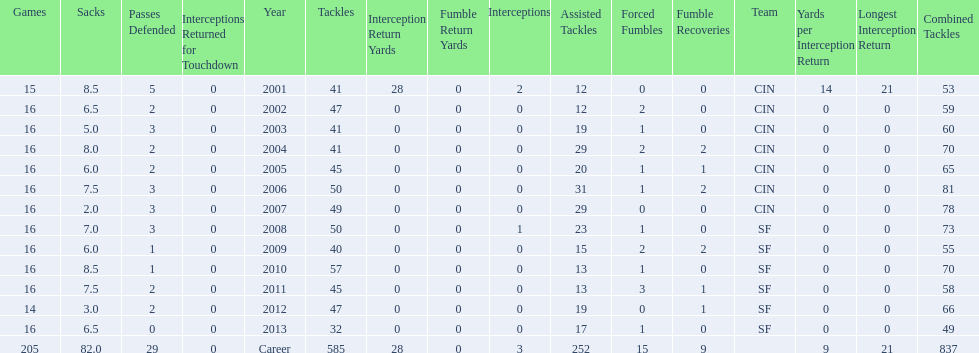Could you help me parse every detail presented in this table? {'header': ['Games', 'Sacks', 'Passes Defended', 'Interceptions Returned for Touchdown', 'Year', 'Tackles', 'Interception Return Yards', 'Fumble Return Yards', 'Interceptions', 'Assisted Tackles', 'Forced Fumbles', 'Fumble Recoveries', 'Team', 'Yards per Interception Return', 'Longest Interception Return', 'Combined Tackles'], 'rows': [['15', '8.5', '5', '0', '2001', '41', '28', '0', '2', '12', '0', '0', 'CIN', '14', '21', '53'], ['16', '6.5', '2', '0', '2002', '47', '0', '0', '0', '12', '2', '0', 'CIN', '0', '0', '59'], ['16', '5.0', '3', '0', '2003', '41', '0', '0', '0', '19', '1', '0', 'CIN', '0', '0', '60'], ['16', '8.0', '2', '0', '2004', '41', '0', '0', '0', '29', '2', '2', 'CIN', '0', '0', '70'], ['16', '6.0', '2', '0', '2005', '45', '0', '0', '0', '20', '1', '1', 'CIN', '0', '0', '65'], ['16', '7.5', '3', '0', '2006', '50', '0', '0', '0', '31', '1', '2', 'CIN', '0', '0', '81'], ['16', '2.0', '3', '0', '2007', '49', '0', '0', '0', '29', '0', '0', 'CIN', '0', '0', '78'], ['16', '7.0', '3', '0', '2008', '50', '0', '0', '1', '23', '1', '0', 'SF', '0', '0', '73'], ['16', '6.0', '1', '0', '2009', '40', '0', '0', '0', '15', '2', '2', 'SF', '0', '0', '55'], ['16', '8.5', '1', '0', '2010', '57', '0', '0', '0', '13', '1', '0', 'SF', '0', '0', '70'], ['16', '7.5', '2', '0', '2011', '45', '0', '0', '0', '13', '3', '1', 'SF', '0', '0', '58'], ['14', '3.0', '2', '0', '2012', '47', '0', '0', '0', '19', '0', '1', 'SF', '0', '0', '66'], ['16', '6.5', '0', '0', '2013', '32', '0', '0', '0', '17', '1', '0', 'SF', '0', '0', '49'], ['205', '82.0', '29', '0', 'Career', '585', '28', '0', '3', '252', '15', '9', '', '9', '21', '837']]} How many consecutive seasons has he played sixteen games? 10. 